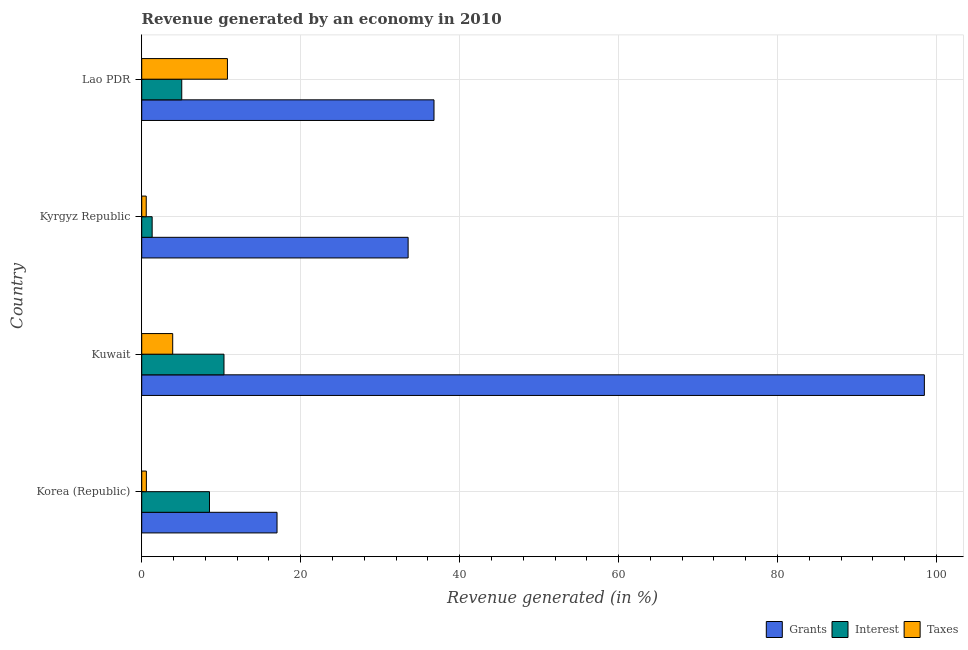How many different coloured bars are there?
Your answer should be compact. 3. How many groups of bars are there?
Offer a very short reply. 4. Are the number of bars per tick equal to the number of legend labels?
Offer a very short reply. Yes. How many bars are there on the 4th tick from the top?
Your response must be concise. 3. How many bars are there on the 4th tick from the bottom?
Ensure brevity in your answer.  3. What is the label of the 3rd group of bars from the top?
Your answer should be compact. Kuwait. What is the percentage of revenue generated by taxes in Korea (Republic)?
Your response must be concise. 0.59. Across all countries, what is the maximum percentage of revenue generated by interest?
Keep it short and to the point. 10.35. Across all countries, what is the minimum percentage of revenue generated by grants?
Offer a terse response. 17.02. In which country was the percentage of revenue generated by taxes maximum?
Keep it short and to the point. Lao PDR. In which country was the percentage of revenue generated by interest minimum?
Offer a terse response. Kyrgyz Republic. What is the total percentage of revenue generated by interest in the graph?
Ensure brevity in your answer.  25.23. What is the difference between the percentage of revenue generated by interest in Kuwait and that in Lao PDR?
Ensure brevity in your answer.  5.32. What is the difference between the percentage of revenue generated by grants in Kuwait and the percentage of revenue generated by interest in Lao PDR?
Offer a very short reply. 93.44. What is the average percentage of revenue generated by interest per country?
Make the answer very short. 6.31. What is the difference between the percentage of revenue generated by taxes and percentage of revenue generated by grants in Kyrgyz Republic?
Offer a terse response. -32.95. In how many countries, is the percentage of revenue generated by interest greater than 80 %?
Provide a succinct answer. 0. What is the ratio of the percentage of revenue generated by taxes in Kuwait to that in Lao PDR?
Ensure brevity in your answer.  0.36. Is the difference between the percentage of revenue generated by taxes in Kyrgyz Republic and Lao PDR greater than the difference between the percentage of revenue generated by interest in Kyrgyz Republic and Lao PDR?
Ensure brevity in your answer.  No. What is the difference between the highest and the second highest percentage of revenue generated by interest?
Your answer should be very brief. 1.83. What is the difference between the highest and the lowest percentage of revenue generated by grants?
Your answer should be very brief. 81.45. In how many countries, is the percentage of revenue generated by interest greater than the average percentage of revenue generated by interest taken over all countries?
Keep it short and to the point. 2. Is the sum of the percentage of revenue generated by taxes in Kyrgyz Republic and Lao PDR greater than the maximum percentage of revenue generated by grants across all countries?
Make the answer very short. No. What does the 3rd bar from the top in Korea (Republic) represents?
Provide a short and direct response. Grants. What does the 3rd bar from the bottom in Kyrgyz Republic represents?
Your answer should be compact. Taxes. Is it the case that in every country, the sum of the percentage of revenue generated by grants and percentage of revenue generated by interest is greater than the percentage of revenue generated by taxes?
Your answer should be compact. Yes. How many bars are there?
Make the answer very short. 12. Are all the bars in the graph horizontal?
Keep it short and to the point. Yes. What is the difference between two consecutive major ticks on the X-axis?
Your answer should be compact. 20. Does the graph contain grids?
Provide a short and direct response. Yes. What is the title of the graph?
Your answer should be compact. Revenue generated by an economy in 2010. What is the label or title of the X-axis?
Make the answer very short. Revenue generated (in %). What is the label or title of the Y-axis?
Make the answer very short. Country. What is the Revenue generated (in %) of Grants in Korea (Republic)?
Keep it short and to the point. 17.02. What is the Revenue generated (in %) of Interest in Korea (Republic)?
Provide a succinct answer. 8.53. What is the Revenue generated (in %) of Taxes in Korea (Republic)?
Provide a succinct answer. 0.59. What is the Revenue generated (in %) in Grants in Kuwait?
Ensure brevity in your answer.  98.47. What is the Revenue generated (in %) of Interest in Kuwait?
Provide a short and direct response. 10.35. What is the Revenue generated (in %) in Taxes in Kuwait?
Make the answer very short. 3.9. What is the Revenue generated (in %) of Grants in Kyrgyz Republic?
Ensure brevity in your answer.  33.52. What is the Revenue generated (in %) of Interest in Kyrgyz Republic?
Give a very brief answer. 1.31. What is the Revenue generated (in %) of Taxes in Kyrgyz Republic?
Give a very brief answer. 0.57. What is the Revenue generated (in %) of Grants in Lao PDR?
Give a very brief answer. 36.78. What is the Revenue generated (in %) of Interest in Lao PDR?
Offer a very short reply. 5.04. What is the Revenue generated (in %) of Taxes in Lao PDR?
Offer a terse response. 10.79. Across all countries, what is the maximum Revenue generated (in %) in Grants?
Make the answer very short. 98.47. Across all countries, what is the maximum Revenue generated (in %) of Interest?
Provide a succinct answer. 10.35. Across all countries, what is the maximum Revenue generated (in %) of Taxes?
Make the answer very short. 10.79. Across all countries, what is the minimum Revenue generated (in %) in Grants?
Make the answer very short. 17.02. Across all countries, what is the minimum Revenue generated (in %) in Interest?
Your response must be concise. 1.31. Across all countries, what is the minimum Revenue generated (in %) of Taxes?
Give a very brief answer. 0.57. What is the total Revenue generated (in %) in Grants in the graph?
Your answer should be very brief. 185.8. What is the total Revenue generated (in %) in Interest in the graph?
Provide a short and direct response. 25.23. What is the total Revenue generated (in %) in Taxes in the graph?
Ensure brevity in your answer.  15.84. What is the difference between the Revenue generated (in %) in Grants in Korea (Republic) and that in Kuwait?
Offer a very short reply. -81.45. What is the difference between the Revenue generated (in %) of Interest in Korea (Republic) and that in Kuwait?
Keep it short and to the point. -1.83. What is the difference between the Revenue generated (in %) of Taxes in Korea (Republic) and that in Kuwait?
Provide a succinct answer. -3.31. What is the difference between the Revenue generated (in %) in Grants in Korea (Republic) and that in Kyrgyz Republic?
Your answer should be compact. -16.5. What is the difference between the Revenue generated (in %) of Interest in Korea (Republic) and that in Kyrgyz Republic?
Your answer should be very brief. 7.21. What is the difference between the Revenue generated (in %) of Taxes in Korea (Republic) and that in Kyrgyz Republic?
Make the answer very short. 0.02. What is the difference between the Revenue generated (in %) of Grants in Korea (Republic) and that in Lao PDR?
Offer a very short reply. -19.75. What is the difference between the Revenue generated (in %) of Interest in Korea (Republic) and that in Lao PDR?
Offer a very short reply. 3.49. What is the difference between the Revenue generated (in %) of Taxes in Korea (Republic) and that in Lao PDR?
Your answer should be very brief. -10.2. What is the difference between the Revenue generated (in %) in Grants in Kuwait and that in Kyrgyz Republic?
Offer a very short reply. 64.95. What is the difference between the Revenue generated (in %) in Interest in Kuwait and that in Kyrgyz Republic?
Ensure brevity in your answer.  9.04. What is the difference between the Revenue generated (in %) in Taxes in Kuwait and that in Kyrgyz Republic?
Offer a very short reply. 3.33. What is the difference between the Revenue generated (in %) of Grants in Kuwait and that in Lao PDR?
Provide a succinct answer. 61.7. What is the difference between the Revenue generated (in %) in Interest in Kuwait and that in Lao PDR?
Keep it short and to the point. 5.31. What is the difference between the Revenue generated (in %) in Taxes in Kuwait and that in Lao PDR?
Give a very brief answer. -6.89. What is the difference between the Revenue generated (in %) of Grants in Kyrgyz Republic and that in Lao PDR?
Provide a short and direct response. -3.26. What is the difference between the Revenue generated (in %) of Interest in Kyrgyz Republic and that in Lao PDR?
Give a very brief answer. -3.72. What is the difference between the Revenue generated (in %) in Taxes in Kyrgyz Republic and that in Lao PDR?
Provide a short and direct response. -10.22. What is the difference between the Revenue generated (in %) in Grants in Korea (Republic) and the Revenue generated (in %) in Interest in Kuwait?
Provide a short and direct response. 6.67. What is the difference between the Revenue generated (in %) in Grants in Korea (Republic) and the Revenue generated (in %) in Taxes in Kuwait?
Your response must be concise. 13.13. What is the difference between the Revenue generated (in %) in Interest in Korea (Republic) and the Revenue generated (in %) in Taxes in Kuwait?
Ensure brevity in your answer.  4.63. What is the difference between the Revenue generated (in %) of Grants in Korea (Republic) and the Revenue generated (in %) of Interest in Kyrgyz Republic?
Offer a terse response. 15.71. What is the difference between the Revenue generated (in %) of Grants in Korea (Republic) and the Revenue generated (in %) of Taxes in Kyrgyz Republic?
Make the answer very short. 16.46. What is the difference between the Revenue generated (in %) in Interest in Korea (Republic) and the Revenue generated (in %) in Taxes in Kyrgyz Republic?
Provide a succinct answer. 7.96. What is the difference between the Revenue generated (in %) of Grants in Korea (Republic) and the Revenue generated (in %) of Interest in Lao PDR?
Offer a very short reply. 11.99. What is the difference between the Revenue generated (in %) of Grants in Korea (Republic) and the Revenue generated (in %) of Taxes in Lao PDR?
Offer a terse response. 6.24. What is the difference between the Revenue generated (in %) in Interest in Korea (Republic) and the Revenue generated (in %) in Taxes in Lao PDR?
Keep it short and to the point. -2.26. What is the difference between the Revenue generated (in %) of Grants in Kuwait and the Revenue generated (in %) of Interest in Kyrgyz Republic?
Keep it short and to the point. 97.16. What is the difference between the Revenue generated (in %) of Grants in Kuwait and the Revenue generated (in %) of Taxes in Kyrgyz Republic?
Your answer should be compact. 97.91. What is the difference between the Revenue generated (in %) of Interest in Kuwait and the Revenue generated (in %) of Taxes in Kyrgyz Republic?
Ensure brevity in your answer.  9.78. What is the difference between the Revenue generated (in %) of Grants in Kuwait and the Revenue generated (in %) of Interest in Lao PDR?
Give a very brief answer. 93.44. What is the difference between the Revenue generated (in %) of Grants in Kuwait and the Revenue generated (in %) of Taxes in Lao PDR?
Your answer should be very brief. 87.69. What is the difference between the Revenue generated (in %) in Interest in Kuwait and the Revenue generated (in %) in Taxes in Lao PDR?
Keep it short and to the point. -0.43. What is the difference between the Revenue generated (in %) of Grants in Kyrgyz Republic and the Revenue generated (in %) of Interest in Lao PDR?
Ensure brevity in your answer.  28.48. What is the difference between the Revenue generated (in %) in Grants in Kyrgyz Republic and the Revenue generated (in %) in Taxes in Lao PDR?
Ensure brevity in your answer.  22.74. What is the difference between the Revenue generated (in %) in Interest in Kyrgyz Republic and the Revenue generated (in %) in Taxes in Lao PDR?
Your response must be concise. -9.47. What is the average Revenue generated (in %) of Grants per country?
Keep it short and to the point. 46.45. What is the average Revenue generated (in %) in Interest per country?
Keep it short and to the point. 6.31. What is the average Revenue generated (in %) of Taxes per country?
Provide a succinct answer. 3.96. What is the difference between the Revenue generated (in %) in Grants and Revenue generated (in %) in Interest in Korea (Republic)?
Provide a short and direct response. 8.5. What is the difference between the Revenue generated (in %) of Grants and Revenue generated (in %) of Taxes in Korea (Republic)?
Keep it short and to the point. 16.44. What is the difference between the Revenue generated (in %) in Interest and Revenue generated (in %) in Taxes in Korea (Republic)?
Make the answer very short. 7.94. What is the difference between the Revenue generated (in %) of Grants and Revenue generated (in %) of Interest in Kuwait?
Your answer should be very brief. 88.12. What is the difference between the Revenue generated (in %) in Grants and Revenue generated (in %) in Taxes in Kuwait?
Your answer should be very brief. 94.58. What is the difference between the Revenue generated (in %) in Interest and Revenue generated (in %) in Taxes in Kuwait?
Make the answer very short. 6.45. What is the difference between the Revenue generated (in %) in Grants and Revenue generated (in %) in Interest in Kyrgyz Republic?
Your answer should be very brief. 32.21. What is the difference between the Revenue generated (in %) of Grants and Revenue generated (in %) of Taxes in Kyrgyz Republic?
Offer a terse response. 32.95. What is the difference between the Revenue generated (in %) in Interest and Revenue generated (in %) in Taxes in Kyrgyz Republic?
Offer a very short reply. 0.74. What is the difference between the Revenue generated (in %) of Grants and Revenue generated (in %) of Interest in Lao PDR?
Make the answer very short. 31.74. What is the difference between the Revenue generated (in %) of Grants and Revenue generated (in %) of Taxes in Lao PDR?
Keep it short and to the point. 25.99. What is the difference between the Revenue generated (in %) of Interest and Revenue generated (in %) of Taxes in Lao PDR?
Make the answer very short. -5.75. What is the ratio of the Revenue generated (in %) of Grants in Korea (Republic) to that in Kuwait?
Keep it short and to the point. 0.17. What is the ratio of the Revenue generated (in %) in Interest in Korea (Republic) to that in Kuwait?
Offer a very short reply. 0.82. What is the ratio of the Revenue generated (in %) in Taxes in Korea (Republic) to that in Kuwait?
Keep it short and to the point. 0.15. What is the ratio of the Revenue generated (in %) in Grants in Korea (Republic) to that in Kyrgyz Republic?
Your answer should be very brief. 0.51. What is the ratio of the Revenue generated (in %) in Interest in Korea (Republic) to that in Kyrgyz Republic?
Provide a short and direct response. 6.5. What is the ratio of the Revenue generated (in %) of Taxes in Korea (Republic) to that in Kyrgyz Republic?
Give a very brief answer. 1.03. What is the ratio of the Revenue generated (in %) of Grants in Korea (Republic) to that in Lao PDR?
Keep it short and to the point. 0.46. What is the ratio of the Revenue generated (in %) in Interest in Korea (Republic) to that in Lao PDR?
Offer a terse response. 1.69. What is the ratio of the Revenue generated (in %) in Taxes in Korea (Republic) to that in Lao PDR?
Your answer should be very brief. 0.05. What is the ratio of the Revenue generated (in %) of Grants in Kuwait to that in Kyrgyz Republic?
Provide a succinct answer. 2.94. What is the ratio of the Revenue generated (in %) of Interest in Kuwait to that in Kyrgyz Republic?
Offer a very short reply. 7.89. What is the ratio of the Revenue generated (in %) in Taxes in Kuwait to that in Kyrgyz Republic?
Your answer should be very brief. 6.87. What is the ratio of the Revenue generated (in %) of Grants in Kuwait to that in Lao PDR?
Your answer should be compact. 2.68. What is the ratio of the Revenue generated (in %) of Interest in Kuwait to that in Lao PDR?
Offer a terse response. 2.06. What is the ratio of the Revenue generated (in %) in Taxes in Kuwait to that in Lao PDR?
Offer a terse response. 0.36. What is the ratio of the Revenue generated (in %) of Grants in Kyrgyz Republic to that in Lao PDR?
Ensure brevity in your answer.  0.91. What is the ratio of the Revenue generated (in %) of Interest in Kyrgyz Republic to that in Lao PDR?
Make the answer very short. 0.26. What is the ratio of the Revenue generated (in %) in Taxes in Kyrgyz Republic to that in Lao PDR?
Ensure brevity in your answer.  0.05. What is the difference between the highest and the second highest Revenue generated (in %) of Grants?
Offer a very short reply. 61.7. What is the difference between the highest and the second highest Revenue generated (in %) in Interest?
Your answer should be compact. 1.83. What is the difference between the highest and the second highest Revenue generated (in %) in Taxes?
Make the answer very short. 6.89. What is the difference between the highest and the lowest Revenue generated (in %) of Grants?
Give a very brief answer. 81.45. What is the difference between the highest and the lowest Revenue generated (in %) in Interest?
Make the answer very short. 9.04. What is the difference between the highest and the lowest Revenue generated (in %) in Taxes?
Keep it short and to the point. 10.22. 